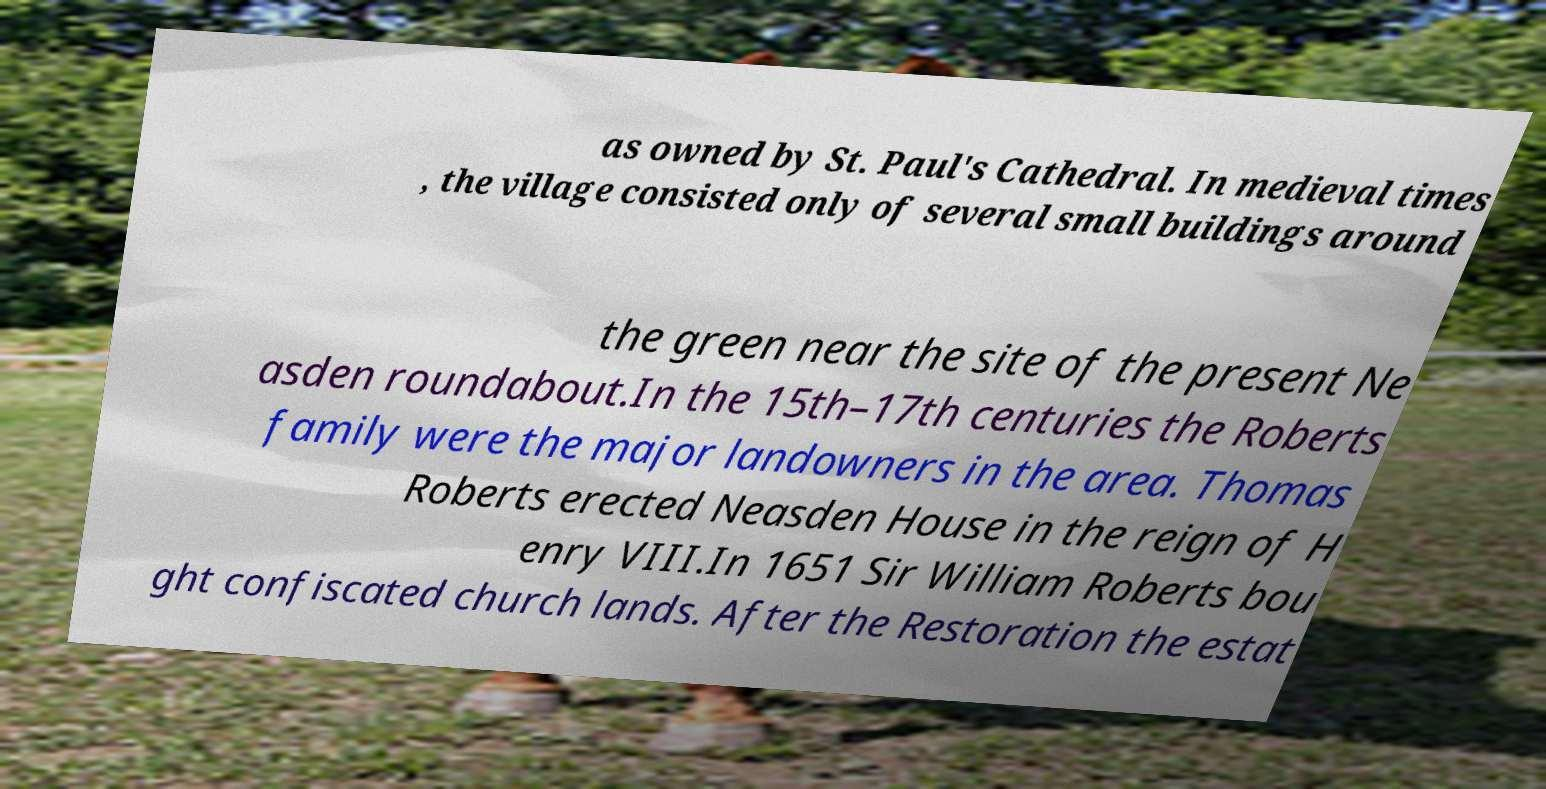Could you assist in decoding the text presented in this image and type it out clearly? as owned by St. Paul's Cathedral. In medieval times , the village consisted only of several small buildings around the green near the site of the present Ne asden roundabout.In the 15th–17th centuries the Roberts family were the major landowners in the area. Thomas Roberts erected Neasden House in the reign of H enry VIII.In 1651 Sir William Roberts bou ght confiscated church lands. After the Restoration the estat 